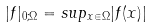Convert formula to latex. <formula><loc_0><loc_0><loc_500><loc_500>| f | _ { 0 ; \Omega } = s u p _ { x \in \Omega } | f ( x ) |</formula> 